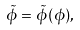<formula> <loc_0><loc_0><loc_500><loc_500>\tilde { \phi } = \tilde { \phi } ( \phi ) ,</formula> 